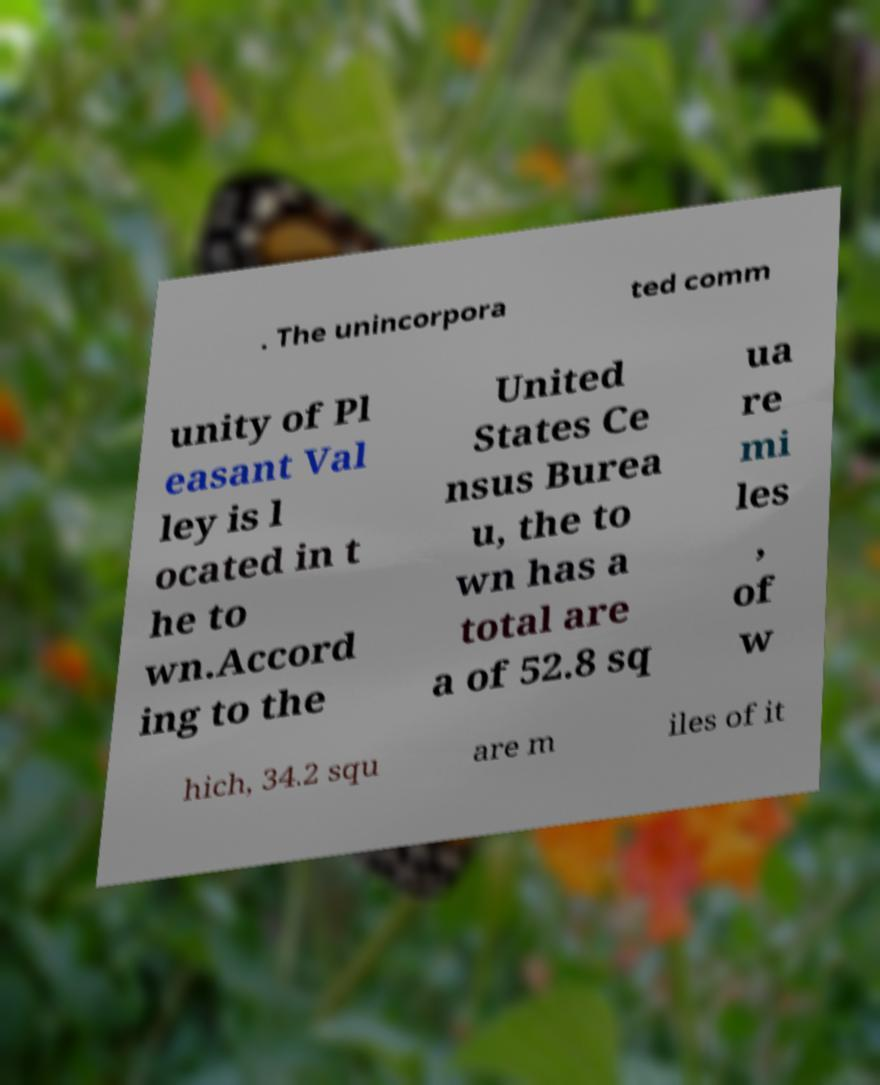There's text embedded in this image that I need extracted. Can you transcribe it verbatim? . The unincorpora ted comm unity of Pl easant Val ley is l ocated in t he to wn.Accord ing to the United States Ce nsus Burea u, the to wn has a total are a of 52.8 sq ua re mi les , of w hich, 34.2 squ are m iles of it 